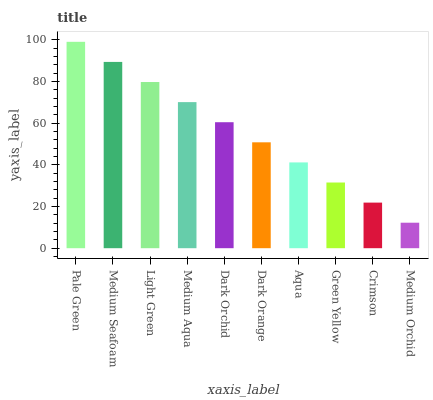Is Medium Orchid the minimum?
Answer yes or no. Yes. Is Pale Green the maximum?
Answer yes or no. Yes. Is Medium Seafoam the minimum?
Answer yes or no. No. Is Medium Seafoam the maximum?
Answer yes or no. No. Is Pale Green greater than Medium Seafoam?
Answer yes or no. Yes. Is Medium Seafoam less than Pale Green?
Answer yes or no. Yes. Is Medium Seafoam greater than Pale Green?
Answer yes or no. No. Is Pale Green less than Medium Seafoam?
Answer yes or no. No. Is Dark Orchid the high median?
Answer yes or no. Yes. Is Dark Orange the low median?
Answer yes or no. Yes. Is Dark Orange the high median?
Answer yes or no. No. Is Medium Seafoam the low median?
Answer yes or no. No. 